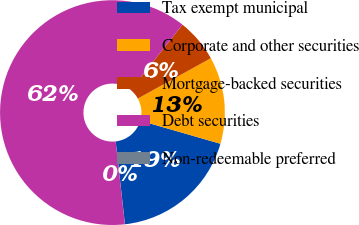Convert chart to OTSL. <chart><loc_0><loc_0><loc_500><loc_500><pie_chart><fcel>Tax exempt municipal<fcel>Corporate and other securities<fcel>Mortgage-backed securities<fcel>Debt securities<fcel>Non-redeemable preferred<nl><fcel>18.75%<fcel>12.51%<fcel>6.26%<fcel>62.47%<fcel>0.01%<nl></chart> 